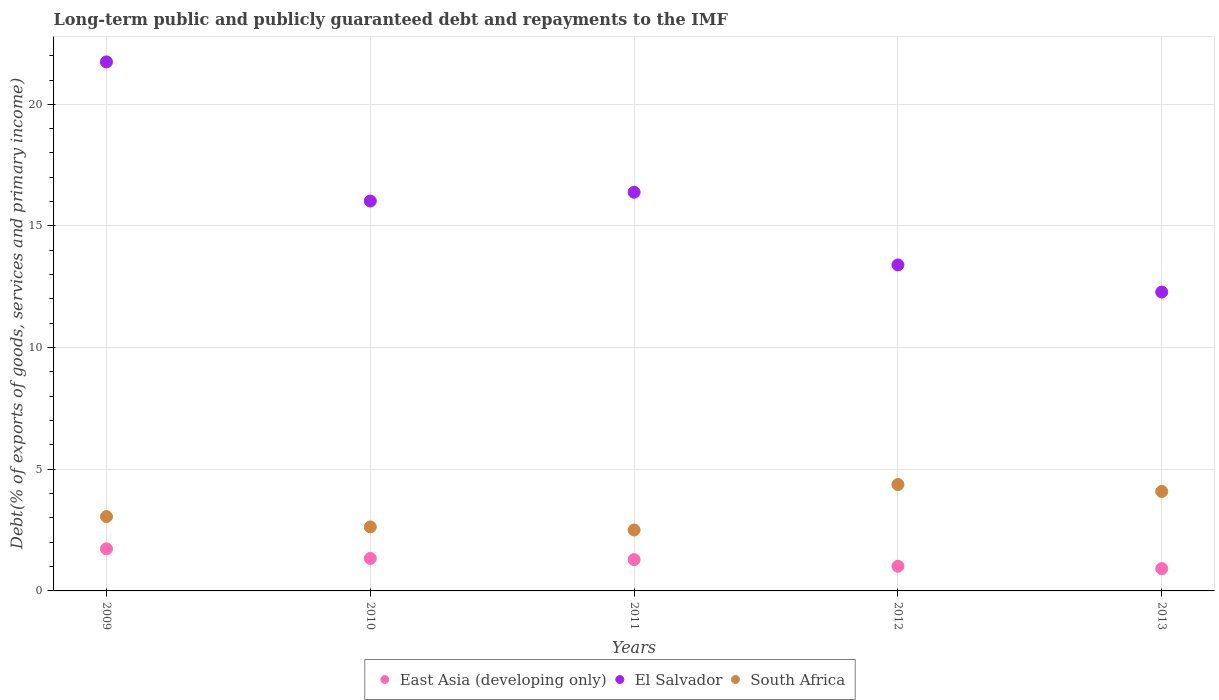How many different coloured dotlines are there?
Provide a succinct answer. 3. What is the debt and repayments in El Salvador in 2013?
Offer a very short reply. 12.28. Across all years, what is the maximum debt and repayments in El Salvador?
Ensure brevity in your answer.  21.74. Across all years, what is the minimum debt and repayments in East Asia (developing only)?
Offer a very short reply. 0.92. In which year was the debt and repayments in El Salvador maximum?
Ensure brevity in your answer.  2009. In which year was the debt and repayments in East Asia (developing only) minimum?
Provide a short and direct response. 2013. What is the total debt and repayments in South Africa in the graph?
Make the answer very short. 16.65. What is the difference between the debt and repayments in El Salvador in 2010 and that in 2013?
Make the answer very short. 3.74. What is the difference between the debt and repayments in East Asia (developing only) in 2009 and the debt and repayments in South Africa in 2012?
Offer a very short reply. -2.64. What is the average debt and repayments in South Africa per year?
Your response must be concise. 3.33. In the year 2009, what is the difference between the debt and repayments in El Salvador and debt and repayments in East Asia (developing only)?
Your answer should be compact. 20.01. In how many years, is the debt and repayments in East Asia (developing only) greater than 4 %?
Make the answer very short. 0. What is the ratio of the debt and repayments in El Salvador in 2009 to that in 2011?
Your answer should be very brief. 1.33. Is the debt and repayments in South Africa in 2010 less than that in 2011?
Offer a terse response. No. What is the difference between the highest and the second highest debt and repayments in El Salvador?
Ensure brevity in your answer.  5.36. What is the difference between the highest and the lowest debt and repayments in East Asia (developing only)?
Offer a very short reply. 0.81. In how many years, is the debt and repayments in South Africa greater than the average debt and repayments in South Africa taken over all years?
Give a very brief answer. 2. Is the sum of the debt and repayments in South Africa in 2011 and 2012 greater than the maximum debt and repayments in East Asia (developing only) across all years?
Your answer should be very brief. Yes. Does the debt and repayments in East Asia (developing only) monotonically increase over the years?
Make the answer very short. No. How many years are there in the graph?
Keep it short and to the point. 5. Are the values on the major ticks of Y-axis written in scientific E-notation?
Your answer should be very brief. No. Does the graph contain any zero values?
Your answer should be very brief. No. Does the graph contain grids?
Your answer should be very brief. Yes. Where does the legend appear in the graph?
Offer a very short reply. Bottom center. How many legend labels are there?
Ensure brevity in your answer.  3. How are the legend labels stacked?
Ensure brevity in your answer.  Horizontal. What is the title of the graph?
Your answer should be compact. Long-term public and publicly guaranteed debt and repayments to the IMF. Does "Mexico" appear as one of the legend labels in the graph?
Provide a short and direct response. No. What is the label or title of the Y-axis?
Give a very brief answer. Debt(% of exports of goods, services and primary income). What is the Debt(% of exports of goods, services and primary income) in East Asia (developing only) in 2009?
Offer a very short reply. 1.73. What is the Debt(% of exports of goods, services and primary income) in El Salvador in 2009?
Keep it short and to the point. 21.74. What is the Debt(% of exports of goods, services and primary income) in South Africa in 2009?
Your response must be concise. 3.06. What is the Debt(% of exports of goods, services and primary income) in East Asia (developing only) in 2010?
Your response must be concise. 1.34. What is the Debt(% of exports of goods, services and primary income) of El Salvador in 2010?
Give a very brief answer. 16.03. What is the Debt(% of exports of goods, services and primary income) in South Africa in 2010?
Keep it short and to the point. 2.63. What is the Debt(% of exports of goods, services and primary income) in East Asia (developing only) in 2011?
Keep it short and to the point. 1.29. What is the Debt(% of exports of goods, services and primary income) of El Salvador in 2011?
Offer a very short reply. 16.39. What is the Debt(% of exports of goods, services and primary income) in South Africa in 2011?
Provide a succinct answer. 2.5. What is the Debt(% of exports of goods, services and primary income) of East Asia (developing only) in 2012?
Keep it short and to the point. 1.01. What is the Debt(% of exports of goods, services and primary income) in El Salvador in 2012?
Give a very brief answer. 13.4. What is the Debt(% of exports of goods, services and primary income) of South Africa in 2012?
Provide a succinct answer. 4.37. What is the Debt(% of exports of goods, services and primary income) in East Asia (developing only) in 2013?
Your response must be concise. 0.92. What is the Debt(% of exports of goods, services and primary income) of El Salvador in 2013?
Your response must be concise. 12.28. What is the Debt(% of exports of goods, services and primary income) of South Africa in 2013?
Ensure brevity in your answer.  4.09. Across all years, what is the maximum Debt(% of exports of goods, services and primary income) in East Asia (developing only)?
Offer a very short reply. 1.73. Across all years, what is the maximum Debt(% of exports of goods, services and primary income) of El Salvador?
Offer a terse response. 21.74. Across all years, what is the maximum Debt(% of exports of goods, services and primary income) of South Africa?
Make the answer very short. 4.37. Across all years, what is the minimum Debt(% of exports of goods, services and primary income) in East Asia (developing only)?
Make the answer very short. 0.92. Across all years, what is the minimum Debt(% of exports of goods, services and primary income) in El Salvador?
Provide a succinct answer. 12.28. Across all years, what is the minimum Debt(% of exports of goods, services and primary income) in South Africa?
Make the answer very short. 2.5. What is the total Debt(% of exports of goods, services and primary income) in East Asia (developing only) in the graph?
Provide a succinct answer. 6.28. What is the total Debt(% of exports of goods, services and primary income) of El Salvador in the graph?
Give a very brief answer. 79.84. What is the total Debt(% of exports of goods, services and primary income) of South Africa in the graph?
Provide a short and direct response. 16.65. What is the difference between the Debt(% of exports of goods, services and primary income) of East Asia (developing only) in 2009 and that in 2010?
Your answer should be compact. 0.39. What is the difference between the Debt(% of exports of goods, services and primary income) in El Salvador in 2009 and that in 2010?
Your response must be concise. 5.72. What is the difference between the Debt(% of exports of goods, services and primary income) in South Africa in 2009 and that in 2010?
Ensure brevity in your answer.  0.42. What is the difference between the Debt(% of exports of goods, services and primary income) of East Asia (developing only) in 2009 and that in 2011?
Your answer should be compact. 0.44. What is the difference between the Debt(% of exports of goods, services and primary income) of El Salvador in 2009 and that in 2011?
Your answer should be very brief. 5.36. What is the difference between the Debt(% of exports of goods, services and primary income) of South Africa in 2009 and that in 2011?
Your answer should be compact. 0.55. What is the difference between the Debt(% of exports of goods, services and primary income) in East Asia (developing only) in 2009 and that in 2012?
Ensure brevity in your answer.  0.72. What is the difference between the Debt(% of exports of goods, services and primary income) in El Salvador in 2009 and that in 2012?
Keep it short and to the point. 8.34. What is the difference between the Debt(% of exports of goods, services and primary income) in South Africa in 2009 and that in 2012?
Your answer should be very brief. -1.32. What is the difference between the Debt(% of exports of goods, services and primary income) of East Asia (developing only) in 2009 and that in 2013?
Offer a very short reply. 0.81. What is the difference between the Debt(% of exports of goods, services and primary income) in El Salvador in 2009 and that in 2013?
Give a very brief answer. 9.46. What is the difference between the Debt(% of exports of goods, services and primary income) in South Africa in 2009 and that in 2013?
Provide a short and direct response. -1.03. What is the difference between the Debt(% of exports of goods, services and primary income) in East Asia (developing only) in 2010 and that in 2011?
Your response must be concise. 0.05. What is the difference between the Debt(% of exports of goods, services and primary income) of El Salvador in 2010 and that in 2011?
Your answer should be very brief. -0.36. What is the difference between the Debt(% of exports of goods, services and primary income) of South Africa in 2010 and that in 2011?
Offer a terse response. 0.13. What is the difference between the Debt(% of exports of goods, services and primary income) in East Asia (developing only) in 2010 and that in 2012?
Make the answer very short. 0.32. What is the difference between the Debt(% of exports of goods, services and primary income) of El Salvador in 2010 and that in 2012?
Your answer should be very brief. 2.63. What is the difference between the Debt(% of exports of goods, services and primary income) in South Africa in 2010 and that in 2012?
Your answer should be very brief. -1.74. What is the difference between the Debt(% of exports of goods, services and primary income) of East Asia (developing only) in 2010 and that in 2013?
Your response must be concise. 0.42. What is the difference between the Debt(% of exports of goods, services and primary income) in El Salvador in 2010 and that in 2013?
Keep it short and to the point. 3.74. What is the difference between the Debt(% of exports of goods, services and primary income) of South Africa in 2010 and that in 2013?
Your answer should be compact. -1.46. What is the difference between the Debt(% of exports of goods, services and primary income) in East Asia (developing only) in 2011 and that in 2012?
Offer a terse response. 0.27. What is the difference between the Debt(% of exports of goods, services and primary income) in El Salvador in 2011 and that in 2012?
Ensure brevity in your answer.  2.99. What is the difference between the Debt(% of exports of goods, services and primary income) of South Africa in 2011 and that in 2012?
Offer a terse response. -1.87. What is the difference between the Debt(% of exports of goods, services and primary income) of East Asia (developing only) in 2011 and that in 2013?
Ensure brevity in your answer.  0.37. What is the difference between the Debt(% of exports of goods, services and primary income) of El Salvador in 2011 and that in 2013?
Offer a terse response. 4.1. What is the difference between the Debt(% of exports of goods, services and primary income) of South Africa in 2011 and that in 2013?
Keep it short and to the point. -1.58. What is the difference between the Debt(% of exports of goods, services and primary income) of East Asia (developing only) in 2012 and that in 2013?
Offer a very short reply. 0.1. What is the difference between the Debt(% of exports of goods, services and primary income) in El Salvador in 2012 and that in 2013?
Keep it short and to the point. 1.12. What is the difference between the Debt(% of exports of goods, services and primary income) in South Africa in 2012 and that in 2013?
Provide a succinct answer. 0.28. What is the difference between the Debt(% of exports of goods, services and primary income) in East Asia (developing only) in 2009 and the Debt(% of exports of goods, services and primary income) in El Salvador in 2010?
Keep it short and to the point. -14.3. What is the difference between the Debt(% of exports of goods, services and primary income) in East Asia (developing only) in 2009 and the Debt(% of exports of goods, services and primary income) in South Africa in 2010?
Your answer should be compact. -0.9. What is the difference between the Debt(% of exports of goods, services and primary income) of El Salvador in 2009 and the Debt(% of exports of goods, services and primary income) of South Africa in 2010?
Provide a short and direct response. 19.11. What is the difference between the Debt(% of exports of goods, services and primary income) of East Asia (developing only) in 2009 and the Debt(% of exports of goods, services and primary income) of El Salvador in 2011?
Your answer should be very brief. -14.66. What is the difference between the Debt(% of exports of goods, services and primary income) of East Asia (developing only) in 2009 and the Debt(% of exports of goods, services and primary income) of South Africa in 2011?
Provide a short and direct response. -0.77. What is the difference between the Debt(% of exports of goods, services and primary income) of El Salvador in 2009 and the Debt(% of exports of goods, services and primary income) of South Africa in 2011?
Make the answer very short. 19.24. What is the difference between the Debt(% of exports of goods, services and primary income) of East Asia (developing only) in 2009 and the Debt(% of exports of goods, services and primary income) of El Salvador in 2012?
Offer a terse response. -11.67. What is the difference between the Debt(% of exports of goods, services and primary income) in East Asia (developing only) in 2009 and the Debt(% of exports of goods, services and primary income) in South Africa in 2012?
Make the answer very short. -2.64. What is the difference between the Debt(% of exports of goods, services and primary income) of El Salvador in 2009 and the Debt(% of exports of goods, services and primary income) of South Africa in 2012?
Your response must be concise. 17.37. What is the difference between the Debt(% of exports of goods, services and primary income) in East Asia (developing only) in 2009 and the Debt(% of exports of goods, services and primary income) in El Salvador in 2013?
Keep it short and to the point. -10.55. What is the difference between the Debt(% of exports of goods, services and primary income) of East Asia (developing only) in 2009 and the Debt(% of exports of goods, services and primary income) of South Africa in 2013?
Give a very brief answer. -2.36. What is the difference between the Debt(% of exports of goods, services and primary income) of El Salvador in 2009 and the Debt(% of exports of goods, services and primary income) of South Africa in 2013?
Provide a succinct answer. 17.66. What is the difference between the Debt(% of exports of goods, services and primary income) of East Asia (developing only) in 2010 and the Debt(% of exports of goods, services and primary income) of El Salvador in 2011?
Your answer should be compact. -15.05. What is the difference between the Debt(% of exports of goods, services and primary income) of East Asia (developing only) in 2010 and the Debt(% of exports of goods, services and primary income) of South Africa in 2011?
Your answer should be very brief. -1.17. What is the difference between the Debt(% of exports of goods, services and primary income) of El Salvador in 2010 and the Debt(% of exports of goods, services and primary income) of South Africa in 2011?
Ensure brevity in your answer.  13.52. What is the difference between the Debt(% of exports of goods, services and primary income) in East Asia (developing only) in 2010 and the Debt(% of exports of goods, services and primary income) in El Salvador in 2012?
Your answer should be compact. -12.06. What is the difference between the Debt(% of exports of goods, services and primary income) in East Asia (developing only) in 2010 and the Debt(% of exports of goods, services and primary income) in South Africa in 2012?
Your response must be concise. -3.04. What is the difference between the Debt(% of exports of goods, services and primary income) of El Salvador in 2010 and the Debt(% of exports of goods, services and primary income) of South Africa in 2012?
Provide a short and direct response. 11.65. What is the difference between the Debt(% of exports of goods, services and primary income) in East Asia (developing only) in 2010 and the Debt(% of exports of goods, services and primary income) in El Salvador in 2013?
Your response must be concise. -10.95. What is the difference between the Debt(% of exports of goods, services and primary income) of East Asia (developing only) in 2010 and the Debt(% of exports of goods, services and primary income) of South Africa in 2013?
Keep it short and to the point. -2.75. What is the difference between the Debt(% of exports of goods, services and primary income) in El Salvador in 2010 and the Debt(% of exports of goods, services and primary income) in South Africa in 2013?
Give a very brief answer. 11.94. What is the difference between the Debt(% of exports of goods, services and primary income) in East Asia (developing only) in 2011 and the Debt(% of exports of goods, services and primary income) in El Salvador in 2012?
Offer a terse response. -12.11. What is the difference between the Debt(% of exports of goods, services and primary income) in East Asia (developing only) in 2011 and the Debt(% of exports of goods, services and primary income) in South Africa in 2012?
Offer a very short reply. -3.09. What is the difference between the Debt(% of exports of goods, services and primary income) in El Salvador in 2011 and the Debt(% of exports of goods, services and primary income) in South Africa in 2012?
Keep it short and to the point. 12.01. What is the difference between the Debt(% of exports of goods, services and primary income) of East Asia (developing only) in 2011 and the Debt(% of exports of goods, services and primary income) of El Salvador in 2013?
Ensure brevity in your answer.  -11. What is the difference between the Debt(% of exports of goods, services and primary income) of East Asia (developing only) in 2011 and the Debt(% of exports of goods, services and primary income) of South Africa in 2013?
Ensure brevity in your answer.  -2.8. What is the difference between the Debt(% of exports of goods, services and primary income) in El Salvador in 2011 and the Debt(% of exports of goods, services and primary income) in South Africa in 2013?
Ensure brevity in your answer.  12.3. What is the difference between the Debt(% of exports of goods, services and primary income) in East Asia (developing only) in 2012 and the Debt(% of exports of goods, services and primary income) in El Salvador in 2013?
Your answer should be very brief. -11.27. What is the difference between the Debt(% of exports of goods, services and primary income) of East Asia (developing only) in 2012 and the Debt(% of exports of goods, services and primary income) of South Africa in 2013?
Offer a terse response. -3.07. What is the difference between the Debt(% of exports of goods, services and primary income) in El Salvador in 2012 and the Debt(% of exports of goods, services and primary income) in South Africa in 2013?
Give a very brief answer. 9.31. What is the average Debt(% of exports of goods, services and primary income) in East Asia (developing only) per year?
Your response must be concise. 1.26. What is the average Debt(% of exports of goods, services and primary income) of El Salvador per year?
Offer a terse response. 15.97. What is the average Debt(% of exports of goods, services and primary income) in South Africa per year?
Offer a very short reply. 3.33. In the year 2009, what is the difference between the Debt(% of exports of goods, services and primary income) of East Asia (developing only) and Debt(% of exports of goods, services and primary income) of El Salvador?
Provide a short and direct response. -20.01. In the year 2009, what is the difference between the Debt(% of exports of goods, services and primary income) in East Asia (developing only) and Debt(% of exports of goods, services and primary income) in South Africa?
Make the answer very short. -1.33. In the year 2009, what is the difference between the Debt(% of exports of goods, services and primary income) in El Salvador and Debt(% of exports of goods, services and primary income) in South Africa?
Your response must be concise. 18.69. In the year 2010, what is the difference between the Debt(% of exports of goods, services and primary income) of East Asia (developing only) and Debt(% of exports of goods, services and primary income) of El Salvador?
Provide a short and direct response. -14.69. In the year 2010, what is the difference between the Debt(% of exports of goods, services and primary income) in East Asia (developing only) and Debt(% of exports of goods, services and primary income) in South Africa?
Your response must be concise. -1.29. In the year 2010, what is the difference between the Debt(% of exports of goods, services and primary income) of El Salvador and Debt(% of exports of goods, services and primary income) of South Africa?
Ensure brevity in your answer.  13.39. In the year 2011, what is the difference between the Debt(% of exports of goods, services and primary income) of East Asia (developing only) and Debt(% of exports of goods, services and primary income) of El Salvador?
Ensure brevity in your answer.  -15.1. In the year 2011, what is the difference between the Debt(% of exports of goods, services and primary income) in East Asia (developing only) and Debt(% of exports of goods, services and primary income) in South Africa?
Keep it short and to the point. -1.22. In the year 2011, what is the difference between the Debt(% of exports of goods, services and primary income) in El Salvador and Debt(% of exports of goods, services and primary income) in South Africa?
Make the answer very short. 13.88. In the year 2012, what is the difference between the Debt(% of exports of goods, services and primary income) of East Asia (developing only) and Debt(% of exports of goods, services and primary income) of El Salvador?
Your response must be concise. -12.39. In the year 2012, what is the difference between the Debt(% of exports of goods, services and primary income) of East Asia (developing only) and Debt(% of exports of goods, services and primary income) of South Africa?
Provide a succinct answer. -3.36. In the year 2012, what is the difference between the Debt(% of exports of goods, services and primary income) of El Salvador and Debt(% of exports of goods, services and primary income) of South Africa?
Provide a succinct answer. 9.03. In the year 2013, what is the difference between the Debt(% of exports of goods, services and primary income) of East Asia (developing only) and Debt(% of exports of goods, services and primary income) of El Salvador?
Offer a very short reply. -11.37. In the year 2013, what is the difference between the Debt(% of exports of goods, services and primary income) of East Asia (developing only) and Debt(% of exports of goods, services and primary income) of South Africa?
Your answer should be compact. -3.17. In the year 2013, what is the difference between the Debt(% of exports of goods, services and primary income) of El Salvador and Debt(% of exports of goods, services and primary income) of South Africa?
Offer a terse response. 8.2. What is the ratio of the Debt(% of exports of goods, services and primary income) of East Asia (developing only) in 2009 to that in 2010?
Your answer should be compact. 1.29. What is the ratio of the Debt(% of exports of goods, services and primary income) in El Salvador in 2009 to that in 2010?
Your answer should be very brief. 1.36. What is the ratio of the Debt(% of exports of goods, services and primary income) in South Africa in 2009 to that in 2010?
Your response must be concise. 1.16. What is the ratio of the Debt(% of exports of goods, services and primary income) in East Asia (developing only) in 2009 to that in 2011?
Give a very brief answer. 1.34. What is the ratio of the Debt(% of exports of goods, services and primary income) in El Salvador in 2009 to that in 2011?
Your answer should be compact. 1.33. What is the ratio of the Debt(% of exports of goods, services and primary income) of South Africa in 2009 to that in 2011?
Offer a terse response. 1.22. What is the ratio of the Debt(% of exports of goods, services and primary income) in East Asia (developing only) in 2009 to that in 2012?
Your answer should be very brief. 1.71. What is the ratio of the Debt(% of exports of goods, services and primary income) in El Salvador in 2009 to that in 2012?
Your answer should be compact. 1.62. What is the ratio of the Debt(% of exports of goods, services and primary income) of South Africa in 2009 to that in 2012?
Give a very brief answer. 0.7. What is the ratio of the Debt(% of exports of goods, services and primary income) of East Asia (developing only) in 2009 to that in 2013?
Provide a short and direct response. 1.89. What is the ratio of the Debt(% of exports of goods, services and primary income) of El Salvador in 2009 to that in 2013?
Give a very brief answer. 1.77. What is the ratio of the Debt(% of exports of goods, services and primary income) in South Africa in 2009 to that in 2013?
Your answer should be very brief. 0.75. What is the ratio of the Debt(% of exports of goods, services and primary income) in East Asia (developing only) in 2010 to that in 2011?
Keep it short and to the point. 1.04. What is the ratio of the Debt(% of exports of goods, services and primary income) in El Salvador in 2010 to that in 2011?
Provide a short and direct response. 0.98. What is the ratio of the Debt(% of exports of goods, services and primary income) of South Africa in 2010 to that in 2011?
Provide a short and direct response. 1.05. What is the ratio of the Debt(% of exports of goods, services and primary income) of East Asia (developing only) in 2010 to that in 2012?
Ensure brevity in your answer.  1.32. What is the ratio of the Debt(% of exports of goods, services and primary income) of El Salvador in 2010 to that in 2012?
Provide a short and direct response. 1.2. What is the ratio of the Debt(% of exports of goods, services and primary income) of South Africa in 2010 to that in 2012?
Provide a succinct answer. 0.6. What is the ratio of the Debt(% of exports of goods, services and primary income) of East Asia (developing only) in 2010 to that in 2013?
Give a very brief answer. 1.46. What is the ratio of the Debt(% of exports of goods, services and primary income) in El Salvador in 2010 to that in 2013?
Make the answer very short. 1.3. What is the ratio of the Debt(% of exports of goods, services and primary income) in South Africa in 2010 to that in 2013?
Your answer should be very brief. 0.64. What is the ratio of the Debt(% of exports of goods, services and primary income) of East Asia (developing only) in 2011 to that in 2012?
Ensure brevity in your answer.  1.27. What is the ratio of the Debt(% of exports of goods, services and primary income) in El Salvador in 2011 to that in 2012?
Keep it short and to the point. 1.22. What is the ratio of the Debt(% of exports of goods, services and primary income) of South Africa in 2011 to that in 2012?
Offer a terse response. 0.57. What is the ratio of the Debt(% of exports of goods, services and primary income) in East Asia (developing only) in 2011 to that in 2013?
Keep it short and to the point. 1.4. What is the ratio of the Debt(% of exports of goods, services and primary income) of El Salvador in 2011 to that in 2013?
Your response must be concise. 1.33. What is the ratio of the Debt(% of exports of goods, services and primary income) of South Africa in 2011 to that in 2013?
Offer a very short reply. 0.61. What is the ratio of the Debt(% of exports of goods, services and primary income) of East Asia (developing only) in 2012 to that in 2013?
Ensure brevity in your answer.  1.11. What is the ratio of the Debt(% of exports of goods, services and primary income) of El Salvador in 2012 to that in 2013?
Offer a terse response. 1.09. What is the ratio of the Debt(% of exports of goods, services and primary income) in South Africa in 2012 to that in 2013?
Keep it short and to the point. 1.07. What is the difference between the highest and the second highest Debt(% of exports of goods, services and primary income) of East Asia (developing only)?
Make the answer very short. 0.39. What is the difference between the highest and the second highest Debt(% of exports of goods, services and primary income) of El Salvador?
Give a very brief answer. 5.36. What is the difference between the highest and the second highest Debt(% of exports of goods, services and primary income) of South Africa?
Your answer should be compact. 0.28. What is the difference between the highest and the lowest Debt(% of exports of goods, services and primary income) of East Asia (developing only)?
Offer a terse response. 0.81. What is the difference between the highest and the lowest Debt(% of exports of goods, services and primary income) in El Salvador?
Give a very brief answer. 9.46. What is the difference between the highest and the lowest Debt(% of exports of goods, services and primary income) in South Africa?
Give a very brief answer. 1.87. 